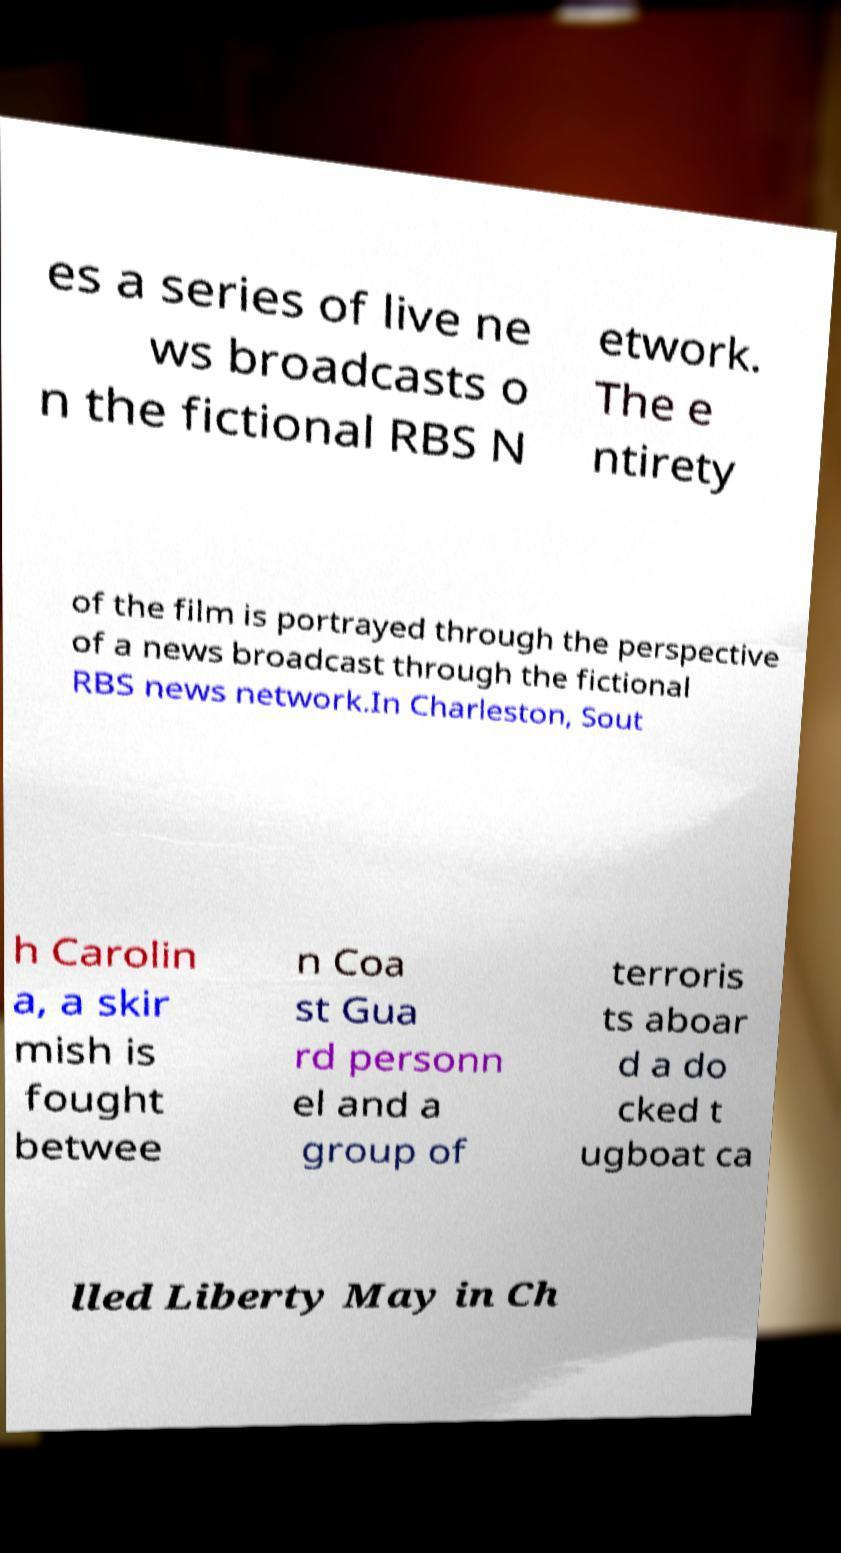Can you read and provide the text displayed in the image?This photo seems to have some interesting text. Can you extract and type it out for me? es a series of live ne ws broadcasts o n the fictional RBS N etwork. The e ntirety of the film is portrayed through the perspective of a news broadcast through the fictional RBS news network.In Charleston, Sout h Carolin a, a skir mish is fought betwee n Coa st Gua rd personn el and a group of terroris ts aboar d a do cked t ugboat ca lled Liberty May in Ch 